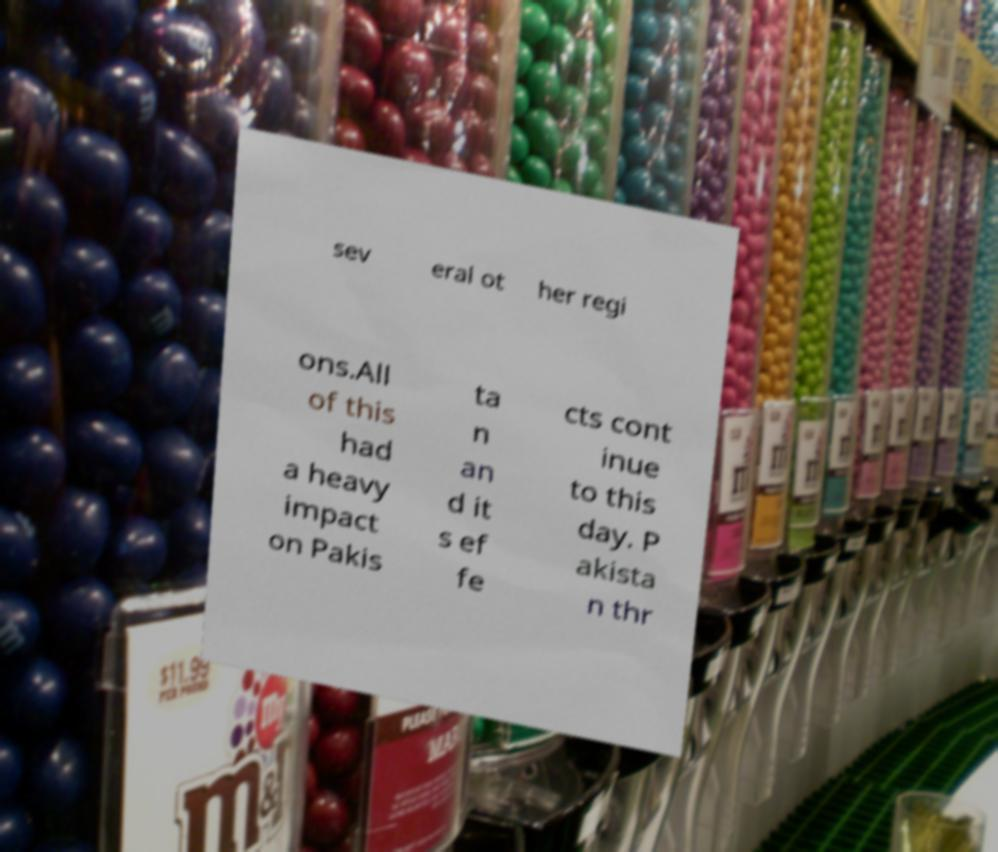For documentation purposes, I need the text within this image transcribed. Could you provide that? sev eral ot her regi ons.All of this had a heavy impact on Pakis ta n an d it s ef fe cts cont inue to this day. P akista n thr 